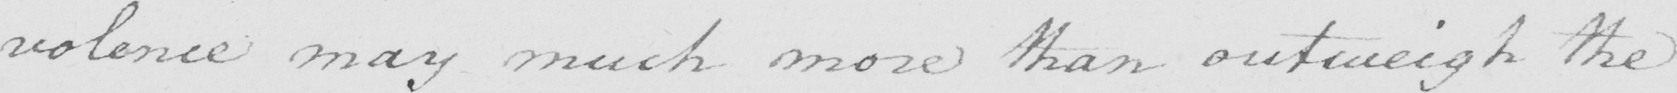Please transcribe the handwritten text in this image. : volence may much more than outweigh the 